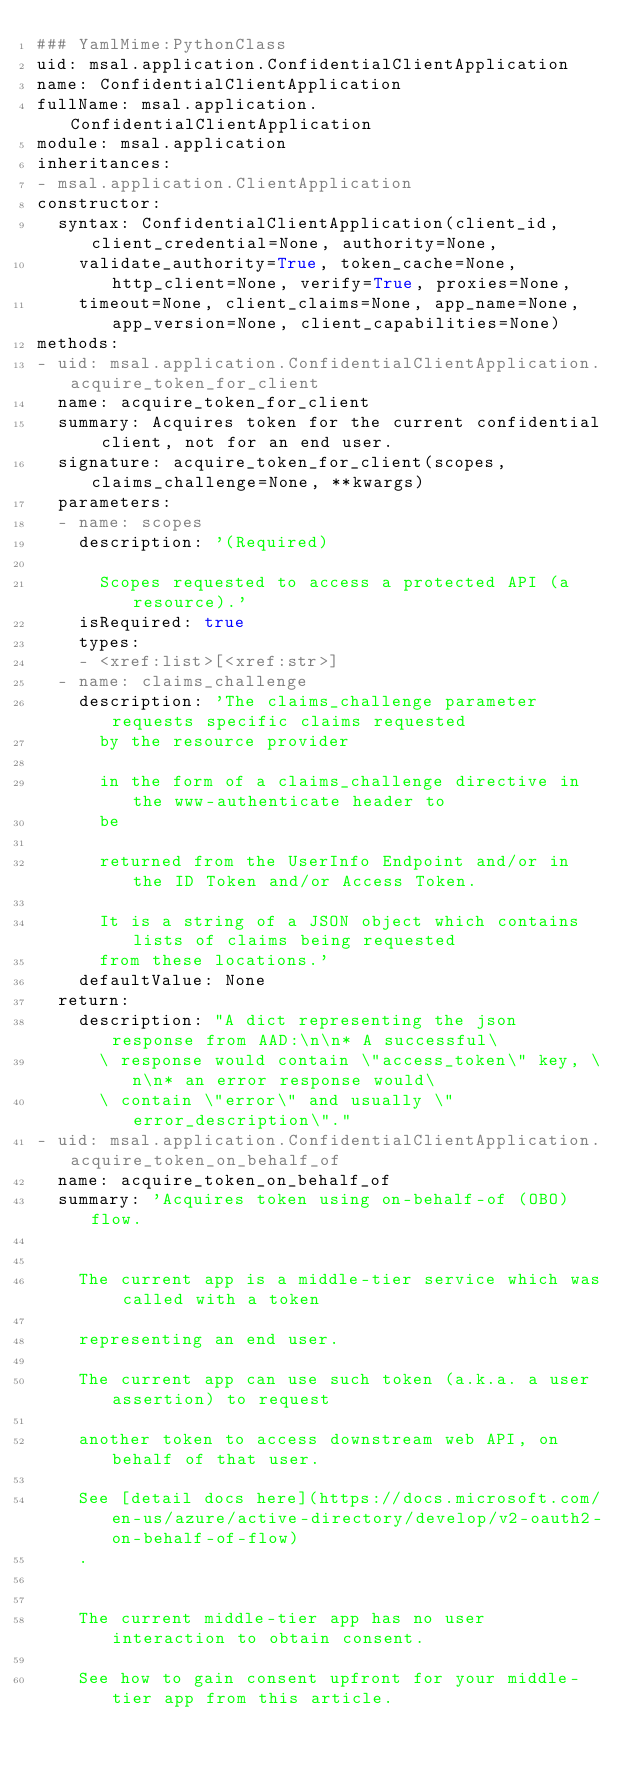<code> <loc_0><loc_0><loc_500><loc_500><_YAML_>### YamlMime:PythonClass
uid: msal.application.ConfidentialClientApplication
name: ConfidentialClientApplication
fullName: msal.application.ConfidentialClientApplication
module: msal.application
inheritances:
- msal.application.ClientApplication
constructor:
  syntax: ConfidentialClientApplication(client_id, client_credential=None, authority=None,
    validate_authority=True, token_cache=None, http_client=None, verify=True, proxies=None,
    timeout=None, client_claims=None, app_name=None, app_version=None, client_capabilities=None)
methods:
- uid: msal.application.ConfidentialClientApplication.acquire_token_for_client
  name: acquire_token_for_client
  summary: Acquires token for the current confidential client, not for an end user.
  signature: acquire_token_for_client(scopes, claims_challenge=None, **kwargs)
  parameters:
  - name: scopes
    description: '(Required)

      Scopes requested to access a protected API (a resource).'
    isRequired: true
    types:
    - <xref:list>[<xref:str>]
  - name: claims_challenge
    description: 'The claims_challenge parameter requests specific claims requested
      by the resource provider

      in the form of a claims_challenge directive in the www-authenticate header to
      be

      returned from the UserInfo Endpoint and/or in the ID Token and/or Access Token.

      It is a string of a JSON object which contains lists of claims being requested
      from these locations.'
    defaultValue: None
  return:
    description: "A dict representing the json response from AAD:\n\n* A successful\
      \ response would contain \"access_token\" key, \n\n* an error response would\
      \ contain \"error\" and usually \"error_description\"."
- uid: msal.application.ConfidentialClientApplication.acquire_token_on_behalf_of
  name: acquire_token_on_behalf_of
  summary: 'Acquires token using on-behalf-of (OBO) flow.


    The current app is a middle-tier service which was called with a token

    representing an end user.

    The current app can use such token (a.k.a. a user assertion) to request

    another token to access downstream web API, on behalf of that user.

    See [detail docs here](https://docs.microsoft.com/en-us/azure/active-directory/develop/v2-oauth2-on-behalf-of-flow)
    .


    The current middle-tier app has no user interaction to obtain consent.

    See how to gain consent upfront for your middle-tier app from this article.
</code> 